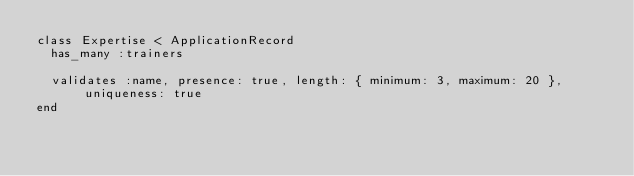<code> <loc_0><loc_0><loc_500><loc_500><_Ruby_>class Expertise < ApplicationRecord
  has_many :trainers

  validates :name, presence: true, length: { minimum: 3, maximum: 20 }, uniqueness: true
end
</code> 